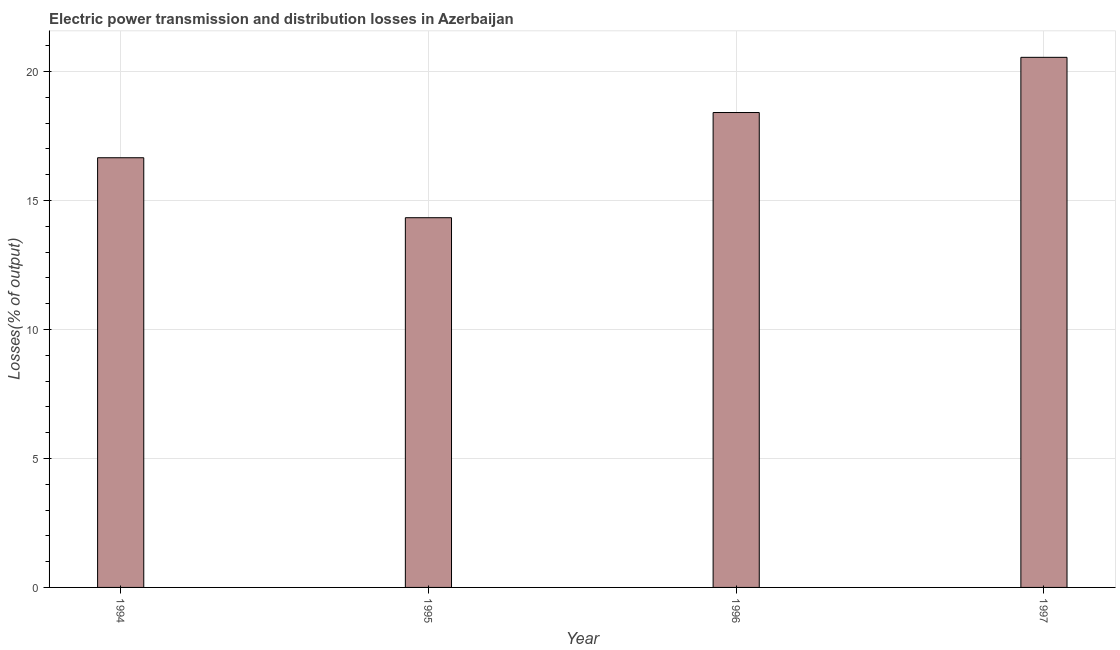What is the title of the graph?
Your response must be concise. Electric power transmission and distribution losses in Azerbaijan. What is the label or title of the X-axis?
Ensure brevity in your answer.  Year. What is the label or title of the Y-axis?
Give a very brief answer. Losses(% of output). What is the electric power transmission and distribution losses in 1996?
Your answer should be very brief. 18.41. Across all years, what is the maximum electric power transmission and distribution losses?
Your answer should be very brief. 20.55. Across all years, what is the minimum electric power transmission and distribution losses?
Ensure brevity in your answer.  14.33. In which year was the electric power transmission and distribution losses maximum?
Give a very brief answer. 1997. In which year was the electric power transmission and distribution losses minimum?
Your answer should be compact. 1995. What is the sum of the electric power transmission and distribution losses?
Give a very brief answer. 69.95. What is the difference between the electric power transmission and distribution losses in 1994 and 1996?
Offer a very short reply. -1.75. What is the average electric power transmission and distribution losses per year?
Provide a short and direct response. 17.49. What is the median electric power transmission and distribution losses?
Offer a terse response. 17.53. What is the ratio of the electric power transmission and distribution losses in 1994 to that in 1995?
Provide a short and direct response. 1.16. What is the difference between the highest and the second highest electric power transmission and distribution losses?
Make the answer very short. 2.14. What is the difference between the highest and the lowest electric power transmission and distribution losses?
Your response must be concise. 6.22. In how many years, is the electric power transmission and distribution losses greater than the average electric power transmission and distribution losses taken over all years?
Make the answer very short. 2. Are all the bars in the graph horizontal?
Ensure brevity in your answer.  No. How many years are there in the graph?
Ensure brevity in your answer.  4. What is the difference between two consecutive major ticks on the Y-axis?
Offer a terse response. 5. Are the values on the major ticks of Y-axis written in scientific E-notation?
Your response must be concise. No. What is the Losses(% of output) in 1994?
Keep it short and to the point. 16.66. What is the Losses(% of output) of 1995?
Ensure brevity in your answer.  14.33. What is the Losses(% of output) of 1996?
Provide a short and direct response. 18.41. What is the Losses(% of output) in 1997?
Keep it short and to the point. 20.55. What is the difference between the Losses(% of output) in 1994 and 1995?
Ensure brevity in your answer.  2.32. What is the difference between the Losses(% of output) in 1994 and 1996?
Offer a terse response. -1.75. What is the difference between the Losses(% of output) in 1994 and 1997?
Make the answer very short. -3.89. What is the difference between the Losses(% of output) in 1995 and 1996?
Provide a succinct answer. -4.08. What is the difference between the Losses(% of output) in 1995 and 1997?
Your response must be concise. -6.22. What is the difference between the Losses(% of output) in 1996 and 1997?
Your answer should be compact. -2.14. What is the ratio of the Losses(% of output) in 1994 to that in 1995?
Make the answer very short. 1.16. What is the ratio of the Losses(% of output) in 1994 to that in 1996?
Your answer should be compact. 0.91. What is the ratio of the Losses(% of output) in 1994 to that in 1997?
Offer a terse response. 0.81. What is the ratio of the Losses(% of output) in 1995 to that in 1996?
Your answer should be compact. 0.78. What is the ratio of the Losses(% of output) in 1995 to that in 1997?
Your answer should be compact. 0.7. What is the ratio of the Losses(% of output) in 1996 to that in 1997?
Make the answer very short. 0.9. 